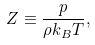Convert formula to latex. <formula><loc_0><loc_0><loc_500><loc_500>Z \equiv \frac { p } { \rho k _ { B } T } ,</formula> 